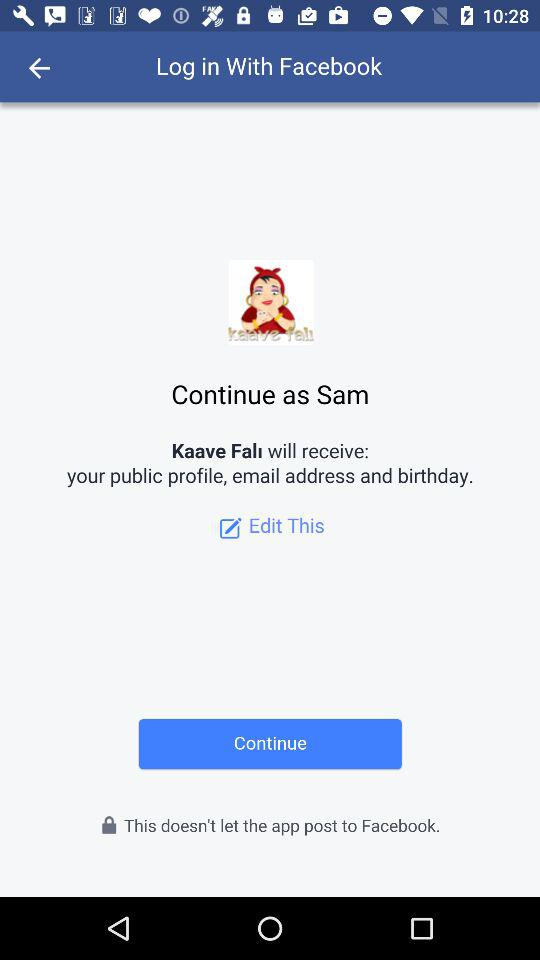What is the name of the user? The name of the user is Sam. 